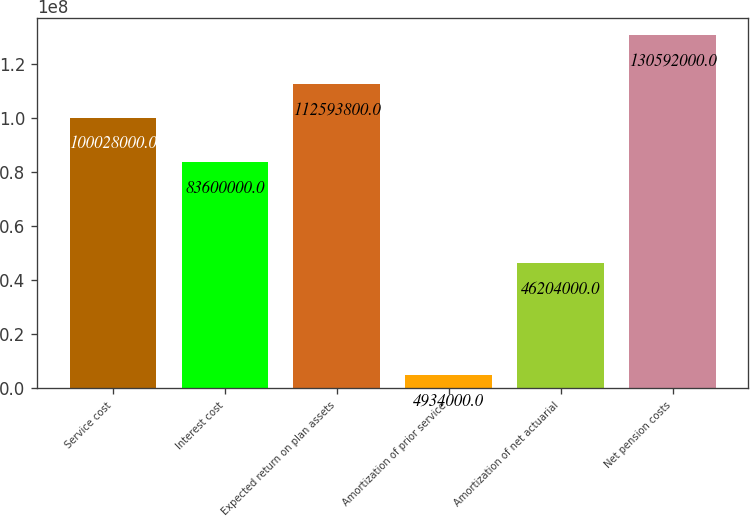<chart> <loc_0><loc_0><loc_500><loc_500><bar_chart><fcel>Service cost<fcel>Interest cost<fcel>Expected return on plan assets<fcel>Amortization of prior service<fcel>Amortization of net actuarial<fcel>Net pension costs<nl><fcel>1.00028e+08<fcel>8.36e+07<fcel>1.12594e+08<fcel>4.934e+06<fcel>4.6204e+07<fcel>1.30592e+08<nl></chart> 